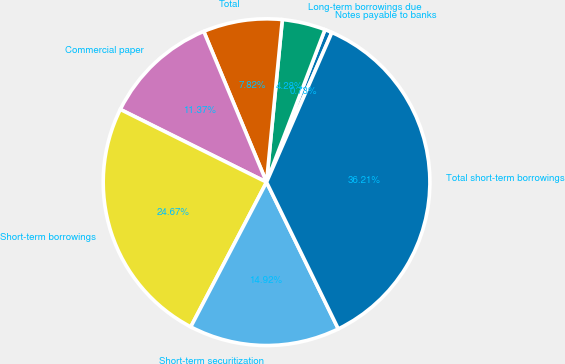Convert chart. <chart><loc_0><loc_0><loc_500><loc_500><pie_chart><fcel>Notes payable to banks<fcel>Long-term borrowings due<fcel>Total<fcel>Commercial paper<fcel>Short-term borrowings<fcel>Short-term securitization<fcel>Total short-term borrowings<nl><fcel>0.73%<fcel>4.28%<fcel>7.82%<fcel>11.37%<fcel>24.67%<fcel>14.92%<fcel>36.21%<nl></chart> 